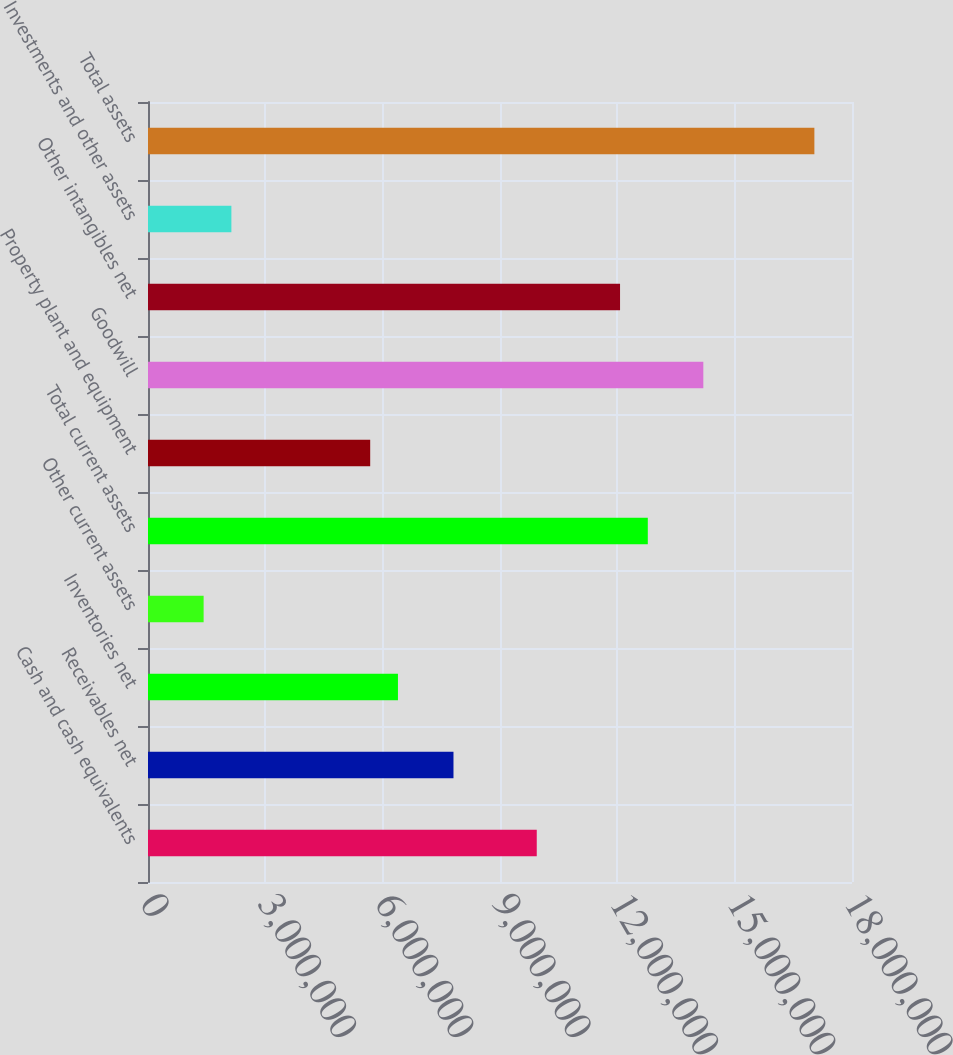Convert chart to OTSL. <chart><loc_0><loc_0><loc_500><loc_500><bar_chart><fcel>Cash and cash equivalents<fcel>Receivables net<fcel>Inventories net<fcel>Other current assets<fcel>Total current assets<fcel>Property plant and equipment<fcel>Goodwill<fcel>Other intangibles net<fcel>Investments and other assets<fcel>Total assets<nl><fcel>9.9399e+06<fcel>7.81048e+06<fcel>6.39087e+06<fcel>1.42223e+06<fcel>1.27791e+07<fcel>5.68106e+06<fcel>1.41987e+07<fcel>1.20693e+07<fcel>2.13203e+06<fcel>1.7038e+07<nl></chart> 